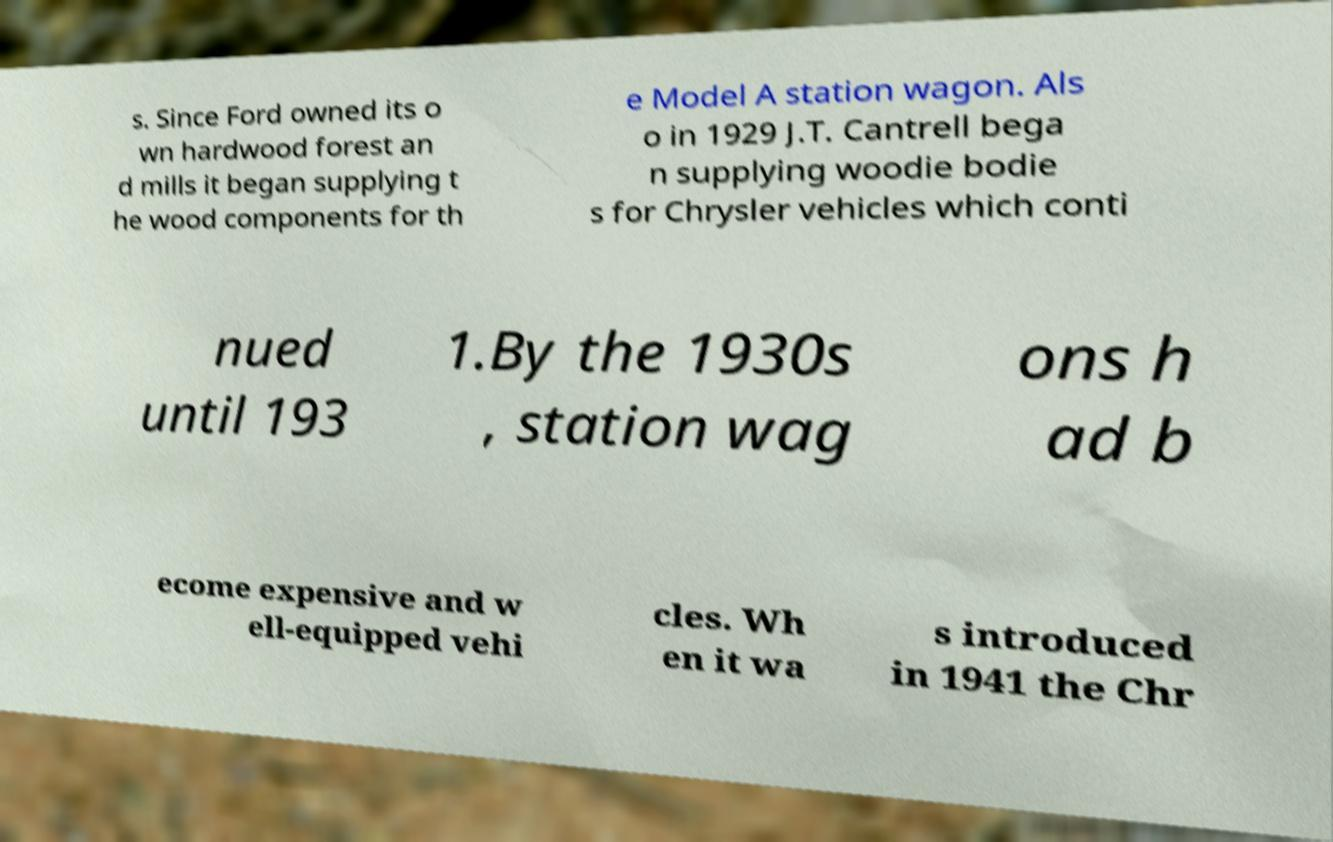There's text embedded in this image that I need extracted. Can you transcribe it verbatim? s. Since Ford owned its o wn hardwood forest an d mills it began supplying t he wood components for th e Model A station wagon. Als o in 1929 J.T. Cantrell bega n supplying woodie bodie s for Chrysler vehicles which conti nued until 193 1.By the 1930s , station wag ons h ad b ecome expensive and w ell-equipped vehi cles. Wh en it wa s introduced in 1941 the Chr 